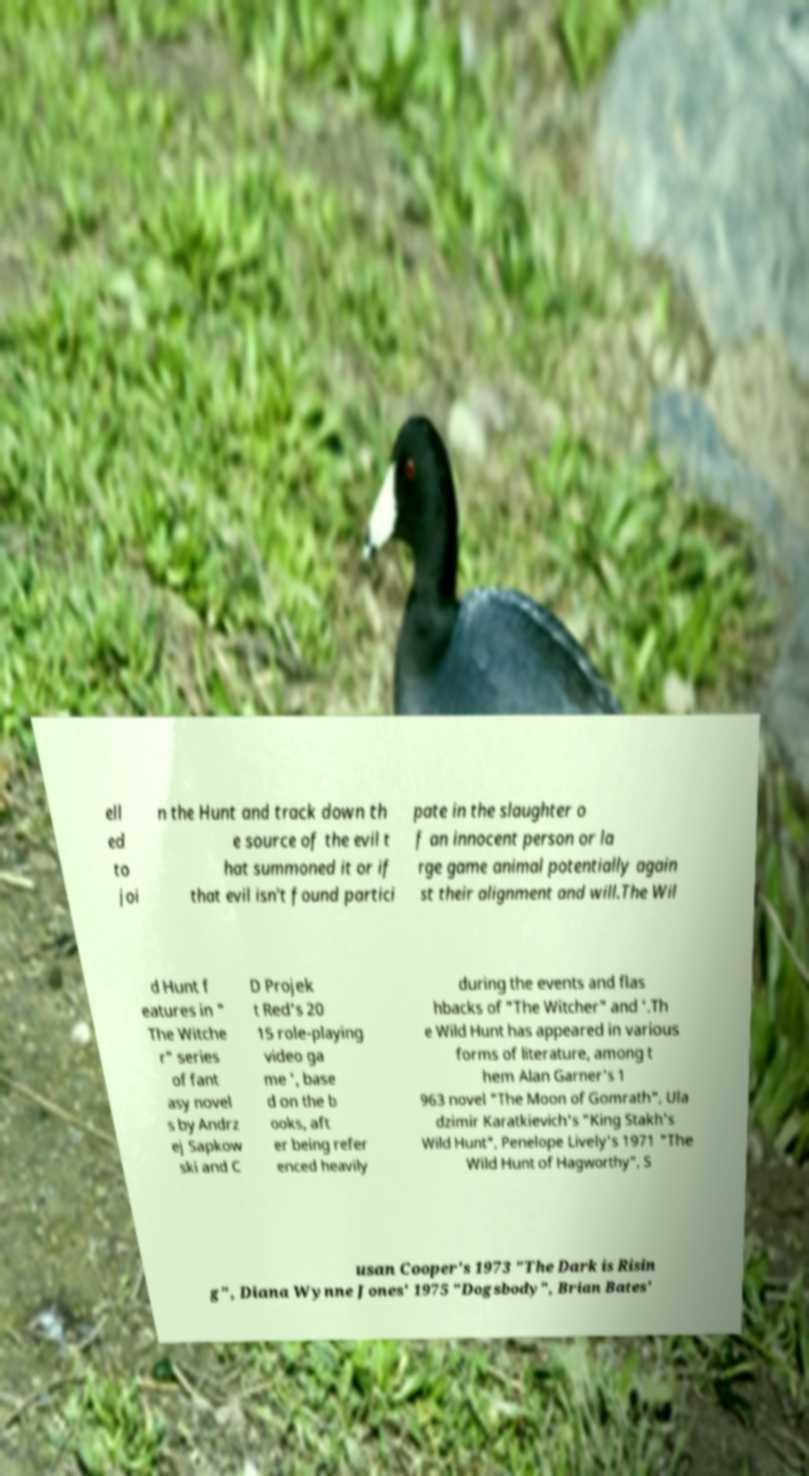Please identify and transcribe the text found in this image. ell ed to joi n the Hunt and track down th e source of the evil t hat summoned it or if that evil isn't found partici pate in the slaughter o f an innocent person or la rge game animal potentially again st their alignment and will.The Wil d Hunt f eatures in " The Witche r" series of fant asy novel s by Andrz ej Sapkow ski and C D Projek t Red's 20 15 role-playing video ga me ', base d on the b ooks, aft er being refer enced heavily during the events and flas hbacks of "The Witcher" and '.Th e Wild Hunt has appeared in various forms of literature, among t hem Alan Garner's 1 963 novel "The Moon of Gomrath", Ula dzimir Karatkievich's "King Stakh's Wild Hunt", Penelope Lively's 1971 "The Wild Hunt of Hagworthy", S usan Cooper's 1973 "The Dark is Risin g", Diana Wynne Jones' 1975 "Dogsbody", Brian Bates' 